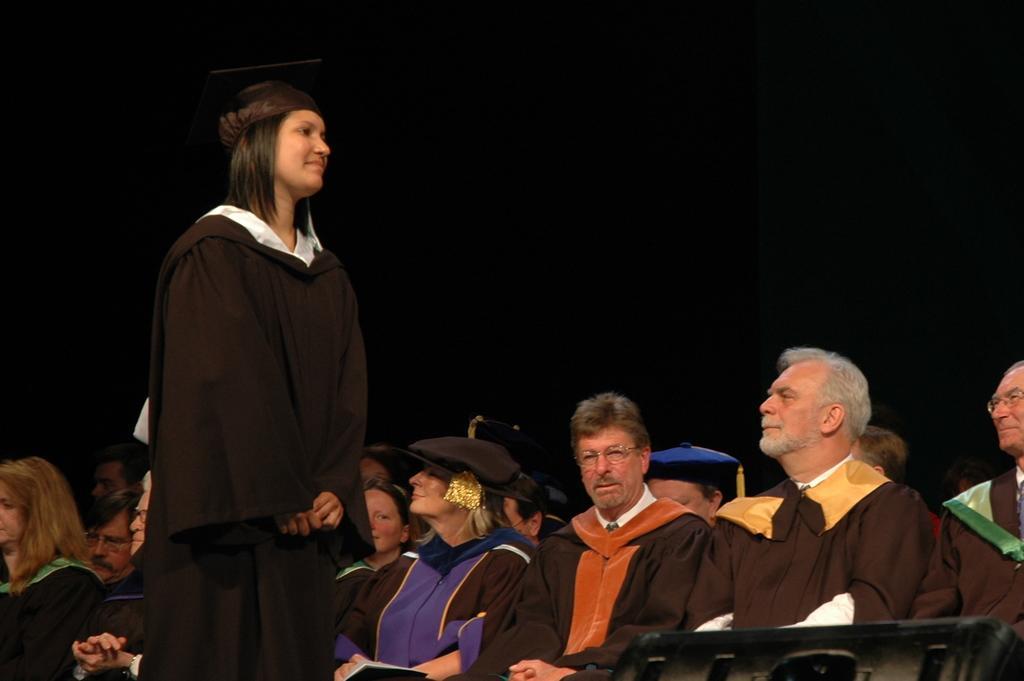How would you summarize this image in a sentence or two? In this image we can see people sitting on chairs. There is a lady standing. The background of the image is black in color. 